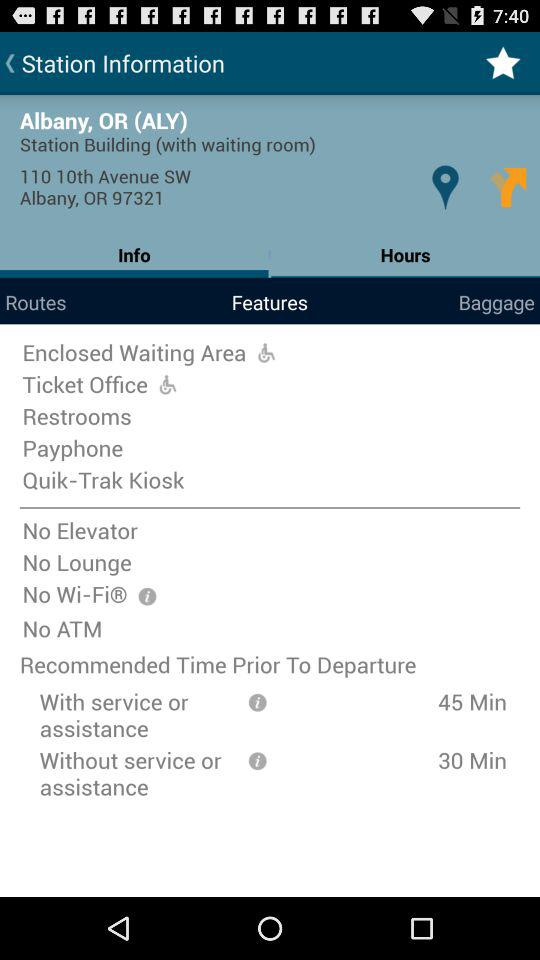What is the difference in recommended time prior to departure for those with or without service or assistance?
Answer the question using a single word or phrase. 15 minutes 